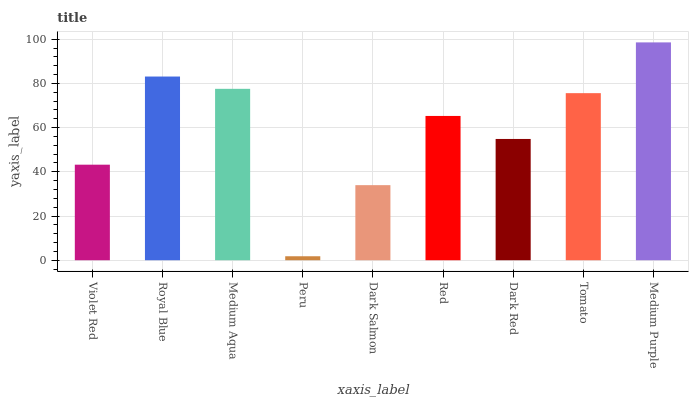Is Peru the minimum?
Answer yes or no. Yes. Is Medium Purple the maximum?
Answer yes or no. Yes. Is Royal Blue the minimum?
Answer yes or no. No. Is Royal Blue the maximum?
Answer yes or no. No. Is Royal Blue greater than Violet Red?
Answer yes or no. Yes. Is Violet Red less than Royal Blue?
Answer yes or no. Yes. Is Violet Red greater than Royal Blue?
Answer yes or no. No. Is Royal Blue less than Violet Red?
Answer yes or no. No. Is Red the high median?
Answer yes or no. Yes. Is Red the low median?
Answer yes or no. Yes. Is Peru the high median?
Answer yes or no. No. Is Medium Purple the low median?
Answer yes or no. No. 